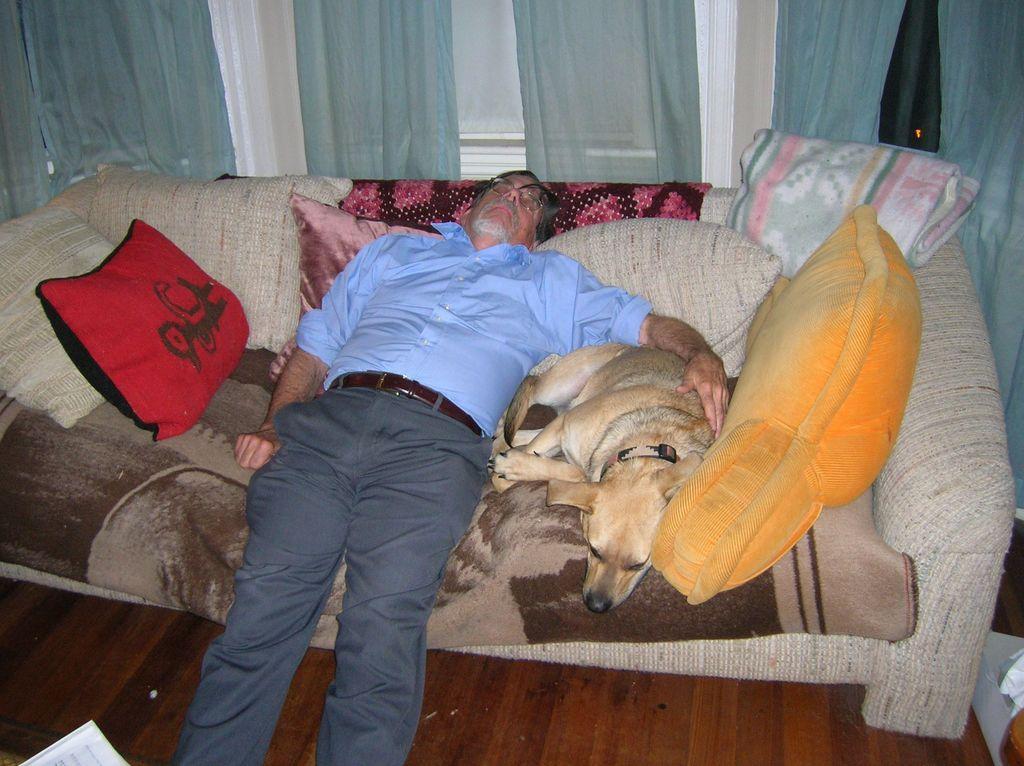Could you give a brief overview of what you see in this image? In this image we can see a person is lying on the sofa and he is keeping his hand on a dog. In the background of the image we can see the curtains. 